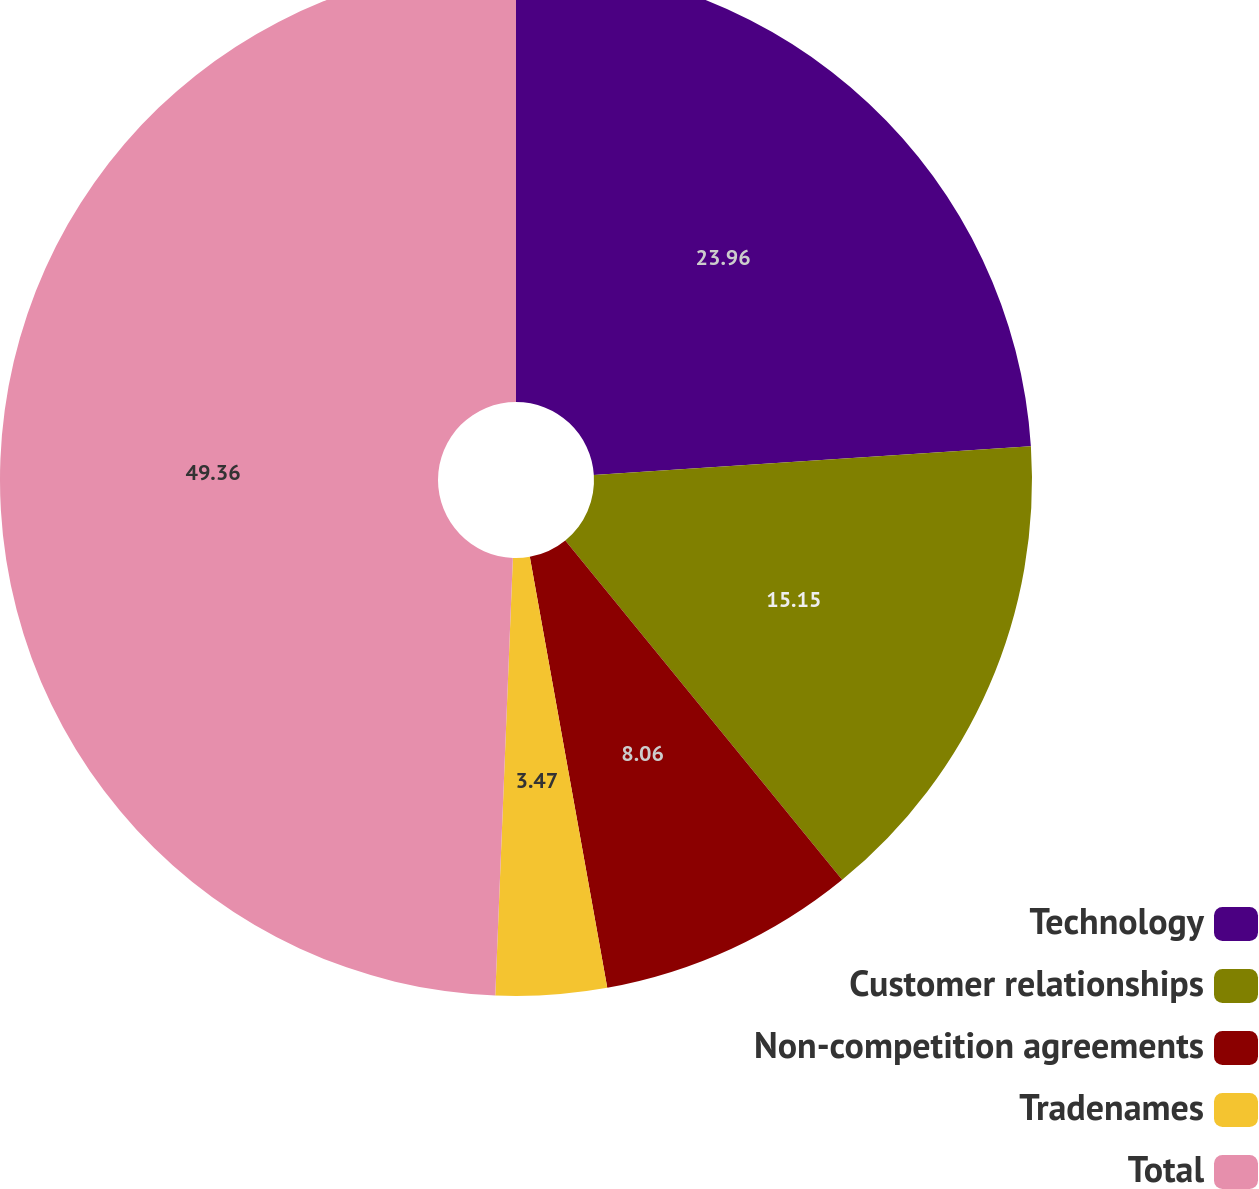<chart> <loc_0><loc_0><loc_500><loc_500><pie_chart><fcel>Technology<fcel>Customer relationships<fcel>Non-competition agreements<fcel>Tradenames<fcel>Total<nl><fcel>23.96%<fcel>15.15%<fcel>8.06%<fcel>3.47%<fcel>49.36%<nl></chart> 